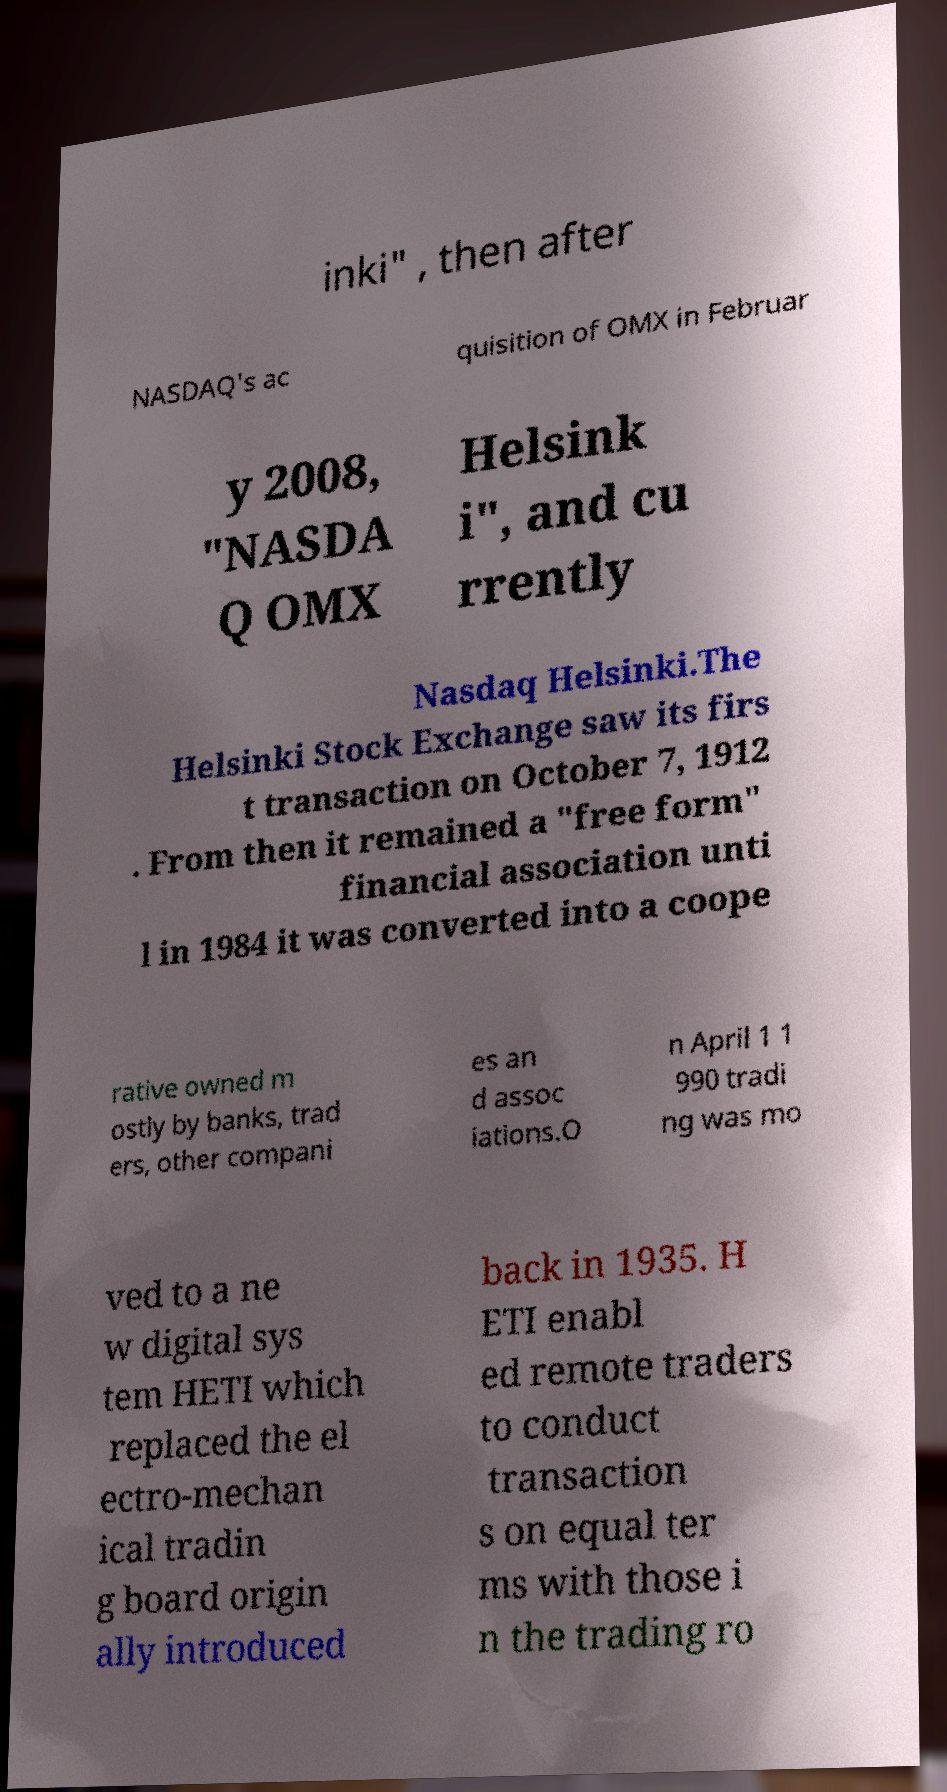Please identify and transcribe the text found in this image. inki" , then after NASDAQ's ac quisition of OMX in Februar y 2008, "NASDA Q OMX Helsink i", and cu rrently Nasdaq Helsinki.The Helsinki Stock Exchange saw its firs t transaction on October 7, 1912 . From then it remained a "free form" financial association unti l in 1984 it was converted into a coope rative owned m ostly by banks, trad ers, other compani es an d assoc iations.O n April 1 1 990 tradi ng was mo ved to a ne w digital sys tem HETI which replaced the el ectro-mechan ical tradin g board origin ally introduced back in 1935. H ETI enabl ed remote traders to conduct transaction s on equal ter ms with those i n the trading ro 